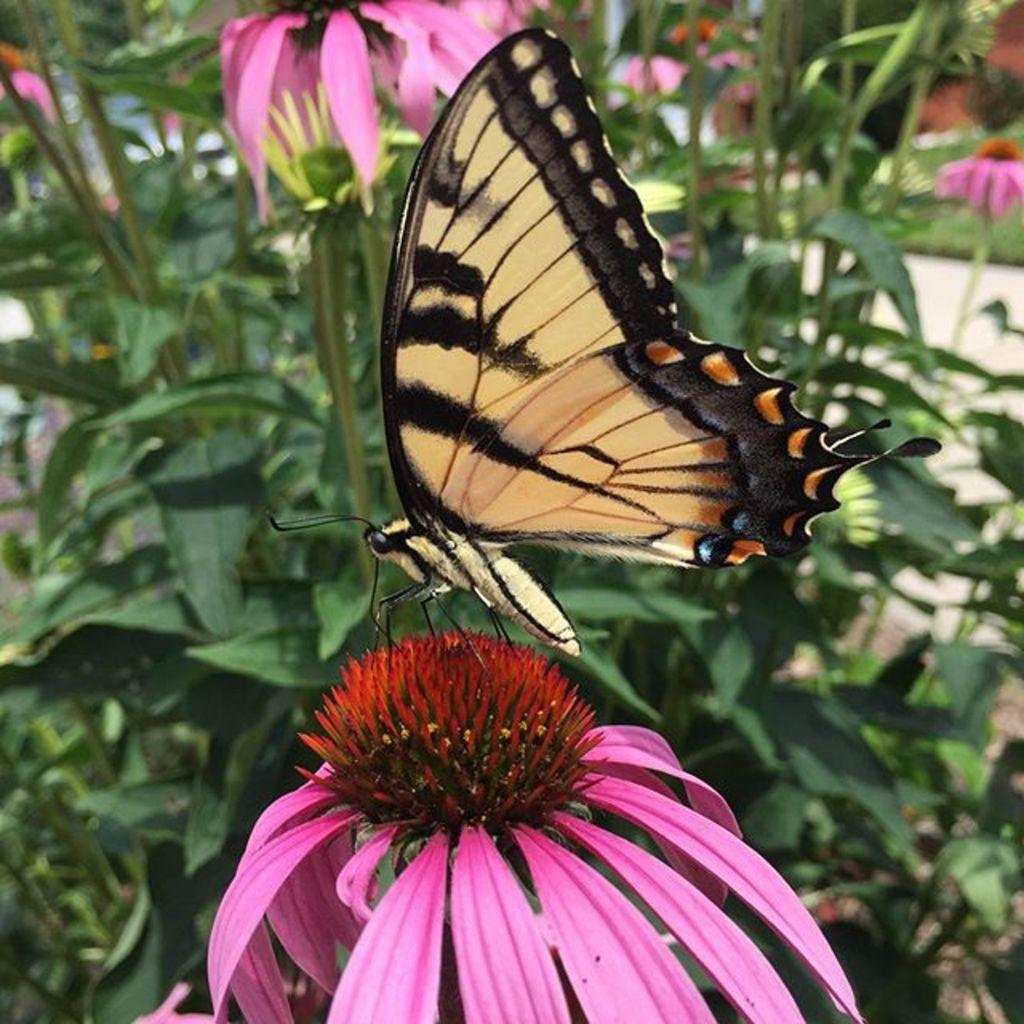What is the main subject of the image? There is a butterfly on a flower in the image. Can you describe the flower the butterfly is on? The butterfly is on a flower, but the specific type of flower is not mentioned in the facts. What can be seen in the background of the image? There are plants with pink and yellow flowers in the background of the image. What type of punishment is the butterfly receiving for landing on the flower in the image? There is no indication of punishment in the image; the butterfly is simply on a flower. How many days are in the week depicted in the image? There is no reference to a week or any time-related elements in the image. 